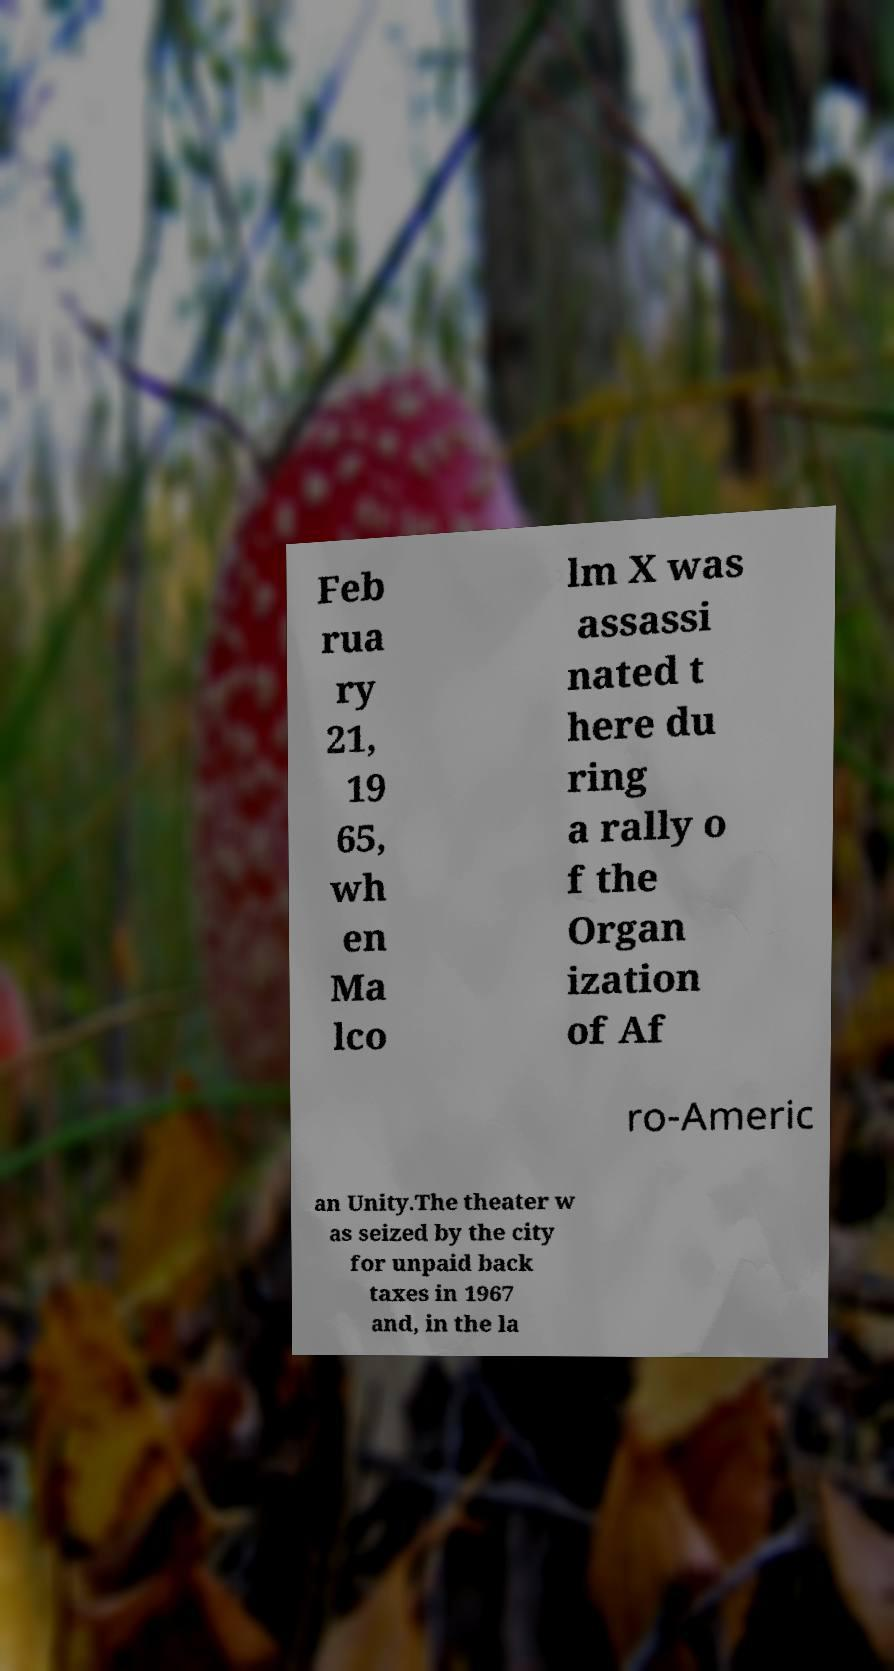What messages or text are displayed in this image? I need them in a readable, typed format. Feb rua ry 21, 19 65, wh en Ma lco lm X was assassi nated t here du ring a rally o f the Organ ization of Af ro-Americ an Unity.The theater w as seized by the city for unpaid back taxes in 1967 and, in the la 